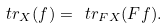<formula> <loc_0><loc_0><loc_500><loc_500>\ t r _ { X } ( f ) = \ t r _ { F X } ( F f ) .</formula> 